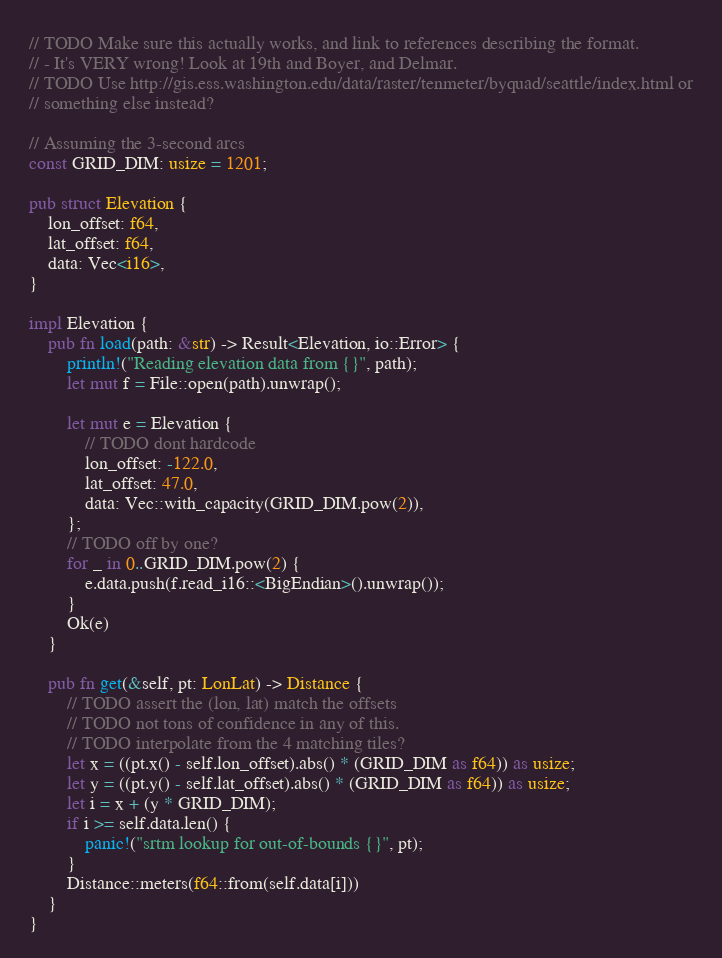Convert code to text. <code><loc_0><loc_0><loc_500><loc_500><_Rust_>// TODO Make sure this actually works, and link to references describing the format.
// - It's VERY wrong! Look at 19th and Boyer, and Delmar.
// TODO Use http://gis.ess.washington.edu/data/raster/tenmeter/byquad/seattle/index.html or
// something else instead?

// Assuming the 3-second arcs
const GRID_DIM: usize = 1201;

pub struct Elevation {
    lon_offset: f64,
    lat_offset: f64,
    data: Vec<i16>,
}

impl Elevation {
    pub fn load(path: &str) -> Result<Elevation, io::Error> {
        println!("Reading elevation data from {}", path);
        let mut f = File::open(path).unwrap();

        let mut e = Elevation {
            // TODO dont hardcode
            lon_offset: -122.0,
            lat_offset: 47.0,
            data: Vec::with_capacity(GRID_DIM.pow(2)),
        };
        // TODO off by one?
        for _ in 0..GRID_DIM.pow(2) {
            e.data.push(f.read_i16::<BigEndian>().unwrap());
        }
        Ok(e)
    }

    pub fn get(&self, pt: LonLat) -> Distance {
        // TODO assert the (lon, lat) match the offsets
        // TODO not tons of confidence in any of this.
        // TODO interpolate from the 4 matching tiles?
        let x = ((pt.x() - self.lon_offset).abs() * (GRID_DIM as f64)) as usize;
        let y = ((pt.y() - self.lat_offset).abs() * (GRID_DIM as f64)) as usize;
        let i = x + (y * GRID_DIM);
        if i >= self.data.len() {
            panic!("srtm lookup for out-of-bounds {}", pt);
        }
        Distance::meters(f64::from(self.data[i]))
    }
}
</code> 